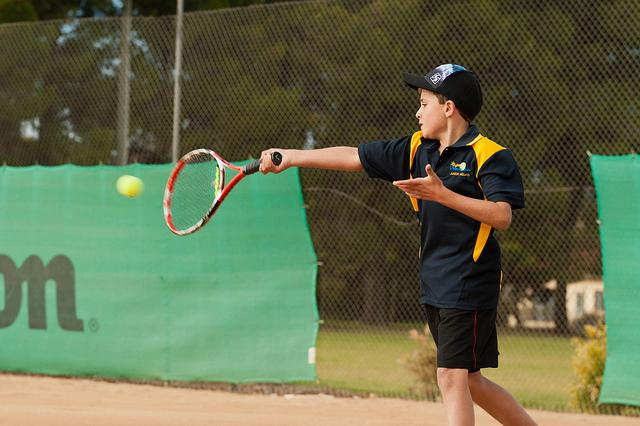Why are there letters on the green banners? sponsors 